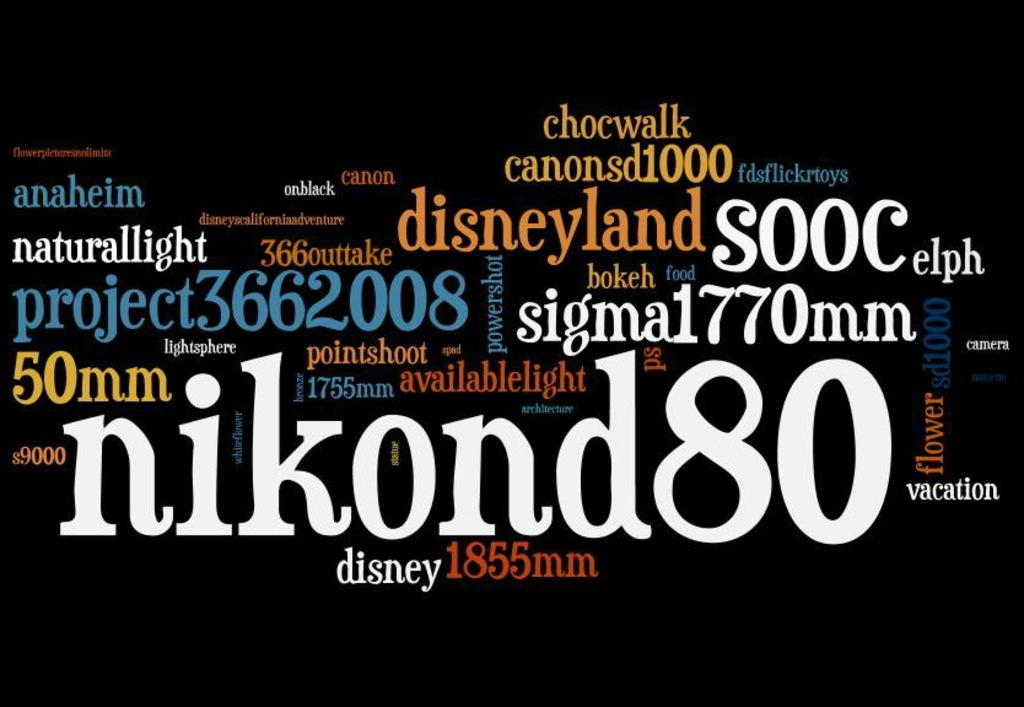<image>
Relay a brief, clear account of the picture shown. A collection of different texts in the same font but different colors read phrases like "disneyland", "chocwalk", and "naturallight" among many others. 